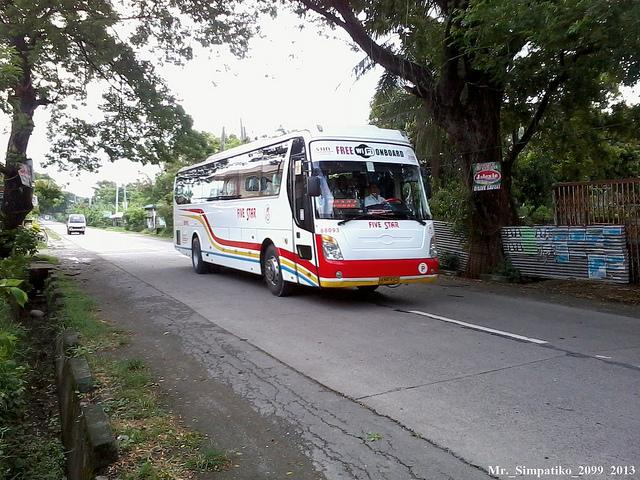What complimentary service does the bus offer on board?

Choices:
A) air-conditioner
B) restrooms
C) wi-fi
D) movies wi-fi 